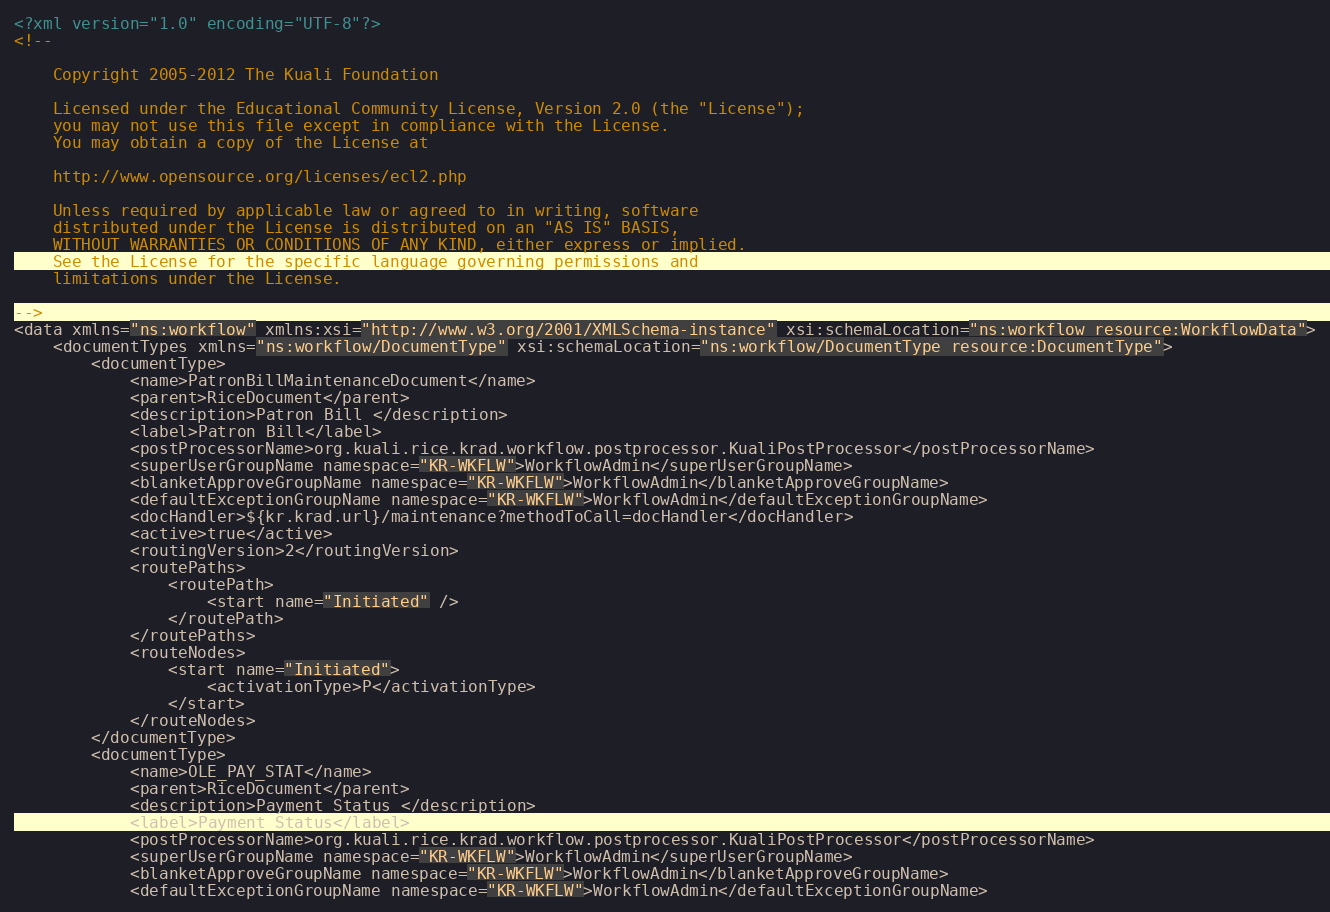<code> <loc_0><loc_0><loc_500><loc_500><_XML_><?xml version="1.0" encoding="UTF-8"?>
<!--

    Copyright 2005-2012 The Kuali Foundation

    Licensed under the Educational Community License, Version 2.0 (the "License");
    you may not use this file except in compliance with the License.
    You may obtain a copy of the License at

    http://www.opensource.org/licenses/ecl2.php

    Unless required by applicable law or agreed to in writing, software
    distributed under the License is distributed on an "AS IS" BASIS,
    WITHOUT WARRANTIES OR CONDITIONS OF ANY KIND, either express or implied.
    See the License for the specific language governing permissions and
    limitations under the License.

-->
<data xmlns="ns:workflow" xmlns:xsi="http://www.w3.org/2001/XMLSchema-instance" xsi:schemaLocation="ns:workflow resource:WorkflowData">
    <documentTypes xmlns="ns:workflow/DocumentType" xsi:schemaLocation="ns:workflow/DocumentType resource:DocumentType">
        <documentType>
            <name>PatronBillMaintenanceDocument</name>
            <parent>RiceDocument</parent>
            <description>Patron Bill </description>
            <label>Patron Bill</label>
            <postProcessorName>org.kuali.rice.krad.workflow.postprocessor.KualiPostProcessor</postProcessorName>
            <superUserGroupName namespace="KR-WKFLW">WorkflowAdmin</superUserGroupName>
            <blanketApproveGroupName namespace="KR-WKFLW">WorkflowAdmin</blanketApproveGroupName>
            <defaultExceptionGroupName namespace="KR-WKFLW">WorkflowAdmin</defaultExceptionGroupName>
            <docHandler>${kr.krad.url}/maintenance?methodToCall=docHandler</docHandler>
            <active>true</active>
            <routingVersion>2</routingVersion>
            <routePaths>
                <routePath>
                    <start name="Initiated" />
                </routePath>
            </routePaths>
            <routeNodes>
                <start name="Initiated">
                    <activationType>P</activationType>
                </start>
            </routeNodes>
        </documentType>
        <documentType>
            <name>OLE_PAY_STAT</name>
            <parent>RiceDocument</parent>
            <description>Payment Status </description>
            <label>Payment Status</label>
            <postProcessorName>org.kuali.rice.krad.workflow.postprocessor.KualiPostProcessor</postProcessorName>
            <superUserGroupName namespace="KR-WKFLW">WorkflowAdmin</superUserGroupName>
            <blanketApproveGroupName namespace="KR-WKFLW">WorkflowAdmin</blanketApproveGroupName>
            <defaultExceptionGroupName namespace="KR-WKFLW">WorkflowAdmin</defaultExceptionGroupName></code> 